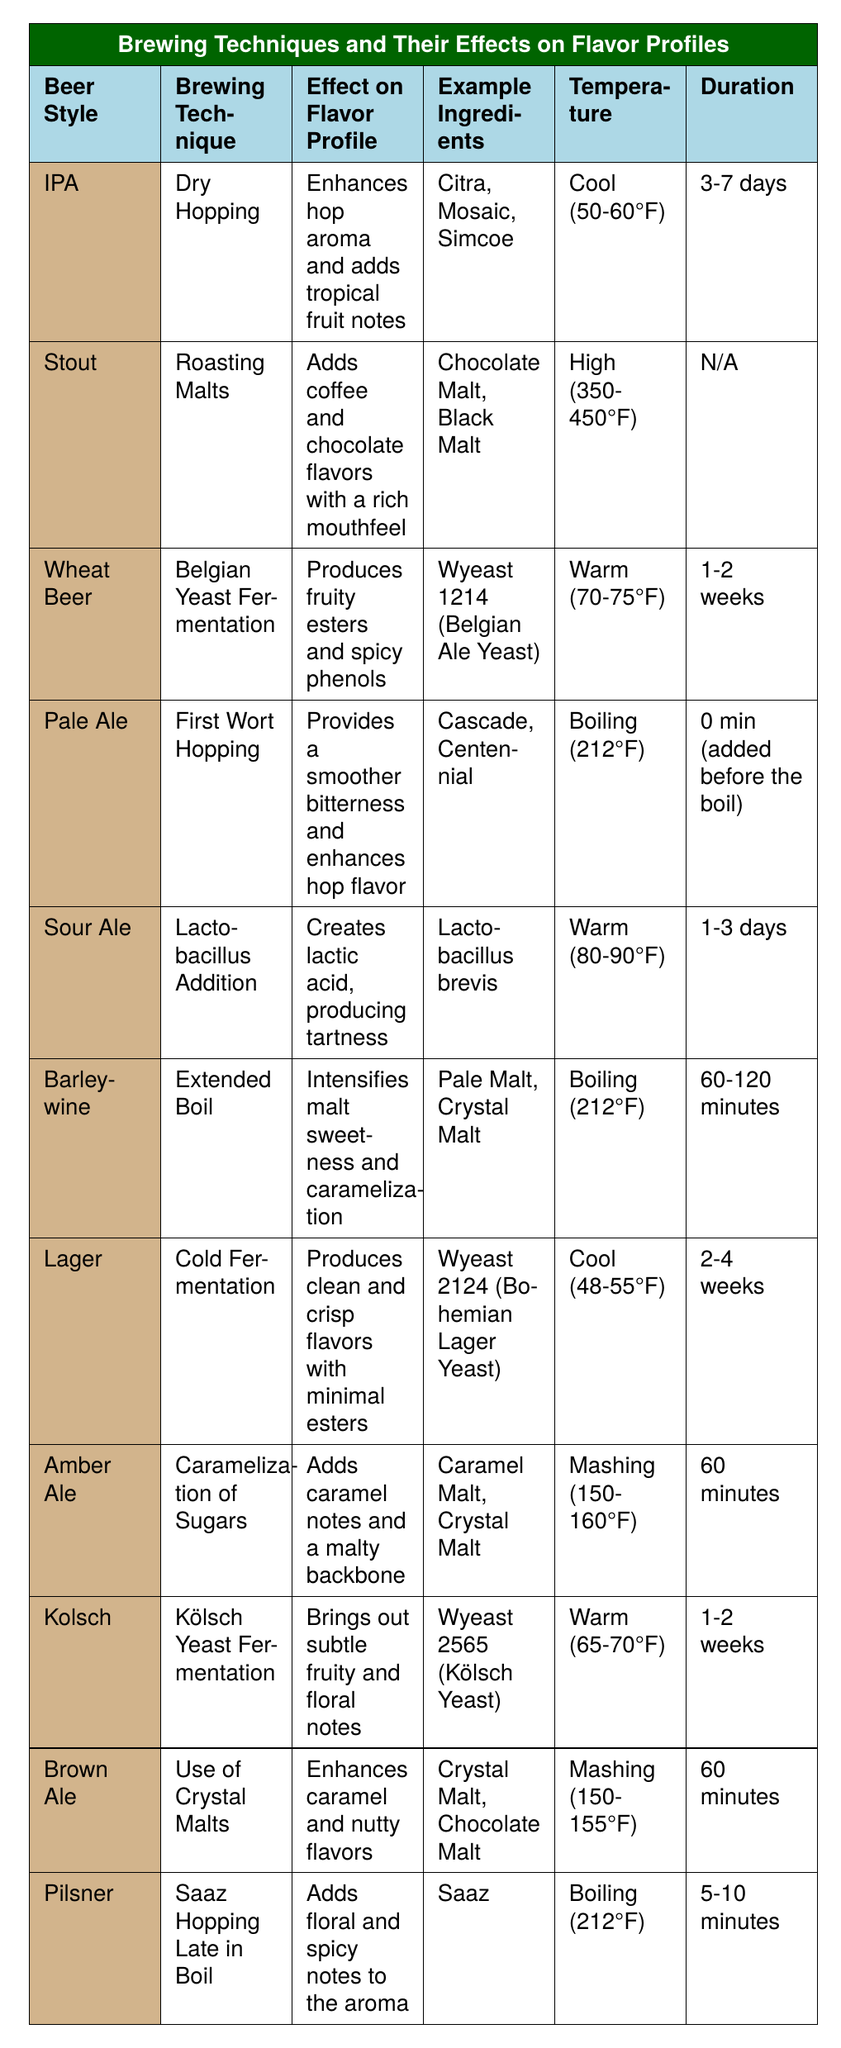What beer style uses dry hopping as a brewing technique? Dry hopping is listed under the brewing technique for the IPA style in the table.
Answer: IPA Which brewing technique is used for Stout? The table indicates that roaming malts is the brewing technique for Stout.
Answer: Roasting Malts What effect does Belgian yeast fermentation have on Wheat Beer? According to the table, Belgian yeast fermentation produces fruity esters and spicy phenols in Wheat Beer.
Answer: Produces fruity esters and spicy phenols Which beer style has the longest fermentation duration? The table shows Lager has a fermentation duration of 2-4 weeks, which is longer than the other styles listed.
Answer: Lager Does Pale Ale use the first wort hopping technique? The table confirms that Pale Ale employs first wort hopping as its brewing technique.
Answer: Yes What temperature is required for cold fermentation? The table specifies that cold fermentation for Lager requires a temperature of 48-55°F.
Answer: 48-55°F Which beer style produces lactic acid? The table indicates that Sour Ale creates lactic acid through Lactobacillus addition.
Answer: Sour Ale Identify the brewing technique for Amber Ale and its effect on the flavor profile. Amber Ale uses caramelization of sugars, which adds caramel notes and creates a malty backbone as described in the table.
Answer: Caramelization of Sugars; Adds caramel notes and malty backbone What are the example hops used in dry hopping for IPA? The table lists Citra, Mosaic, and Simcoe as the example hops used for dry hopping in IPA.
Answer: Citra, Mosaic, Simcoe If a recipe uses Saaz hops late in the boil, which beer style is it most likely associated with? According to the table, Saaz hopping late in the boil is associated with Pilsner.
Answer: Pilsner What is the average fermentation duration for the beer styles listed? The durations are: Wheat Beer (1-2 weeks), Lager (2-4 weeks), Kolsch (1-2 weeks), and Sour Ale (1-3 days). To average them, convert to days ([1.5 + 21 + 10.5 + 2]). The total is 35 days, so the average duration is approximately 8.75 days.
Answer: 8.75 days What specific effect does an extended boil have on Barleywine? The table explains that an extended boil intensifies malt sweetness and caramelization for Barleywine.
Answer: Intensifies malt sweetness and caramelization Is it true that Brown Ale enhances caramel flavors using roasted malts? The table confirms that Brown Ale enhances caramel flavors using crystal malts, not roasted malts. Thus, the statement is false.
Answer: No 